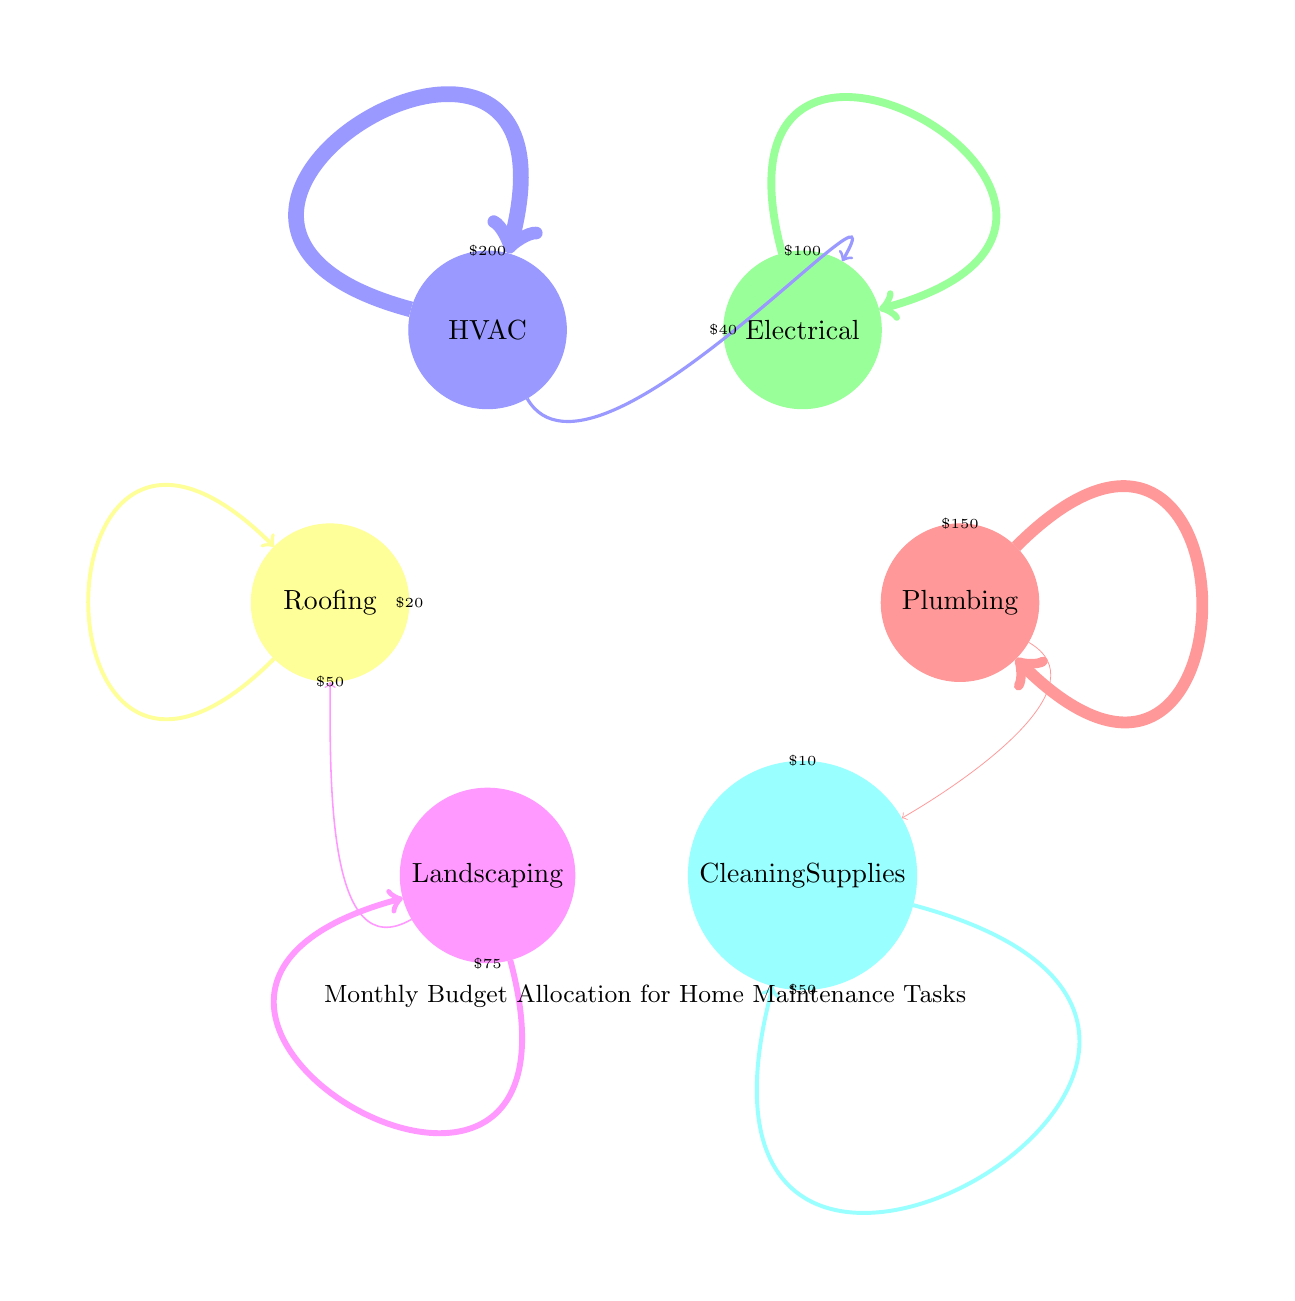What is the budget allocated for HVAC? The diagram indicates that the budget allocated for HVAC is distinctly labeled and associated with the node 'HVAC'. Upon checking this specific node, it shows a value of 200.
Answer: 200 Which area has the lowest budget allocation? We can review all nodes in the diagram to find the smallest value. Among Plumbing (150), Electrical (100), HVAC (200), Roofing (50), Landscaping (75), and Cleaning Supplies (50), both Roofing and Cleaning Supplies have the lowest at 50. Since Cleaning Supplies is considered first in an informal sense, it can be categorized as the one with the lowest budget.
Answer: Cleaning Supplies How much budget is allocated for Landscaping? Looking into the node labeled 'Landscaping', the diagram clearly shows that this area has a budget allocation of 75. This is a straightforward read from the node's label.
Answer: 75 What is the budget flow from HVAC to Electrical? The diagram illustrates a directed flow (arrow) coming from node 'HVAC' to node 'Electrical'. Upon examining the specifics of this arrow, it shows a value of 40, indicating this flow direction.
Answer: 40 How many maintenance areas have a budget of more than 100? By inspecting the values assigned to each node in the diagram: Plumbing (150), Electrical (100), HVAC (200), Roofing (50), Landscaping (75), and Cleaning Supplies (50), we see that only Plumbing and HVAC exceed 100. Therefore, we have two areas with budgets over 100.
Answer: 2 Which maintenance task receives the highest funding? A review of all the nodes indicates the highest financial allocation. The allocation for HVAC is 200, which is clearly the greatest compared to others such as Plumbing at 150 and the rest are lower. Thus, HVAC holds the top position in funding.
Answer: HVAC What is the total budget for Plumbing and Cleaning Supplies? To find the total budget, we sum the values of both nodes. Plumbing is allocated 150, and Cleaning Supplies is 50. Adding these together, 150 + 50 results in a total of 200 for the mentioned areas.
Answer: 200 Is there a direct financial relationship from Landscaping to Roofing? Checking the diagram, there is indeed an arrow pointing from Landscaping to Roofing. This arrow indicates a budget flow of 20, meaning there is a direct financial link represented.
Answer: 20 